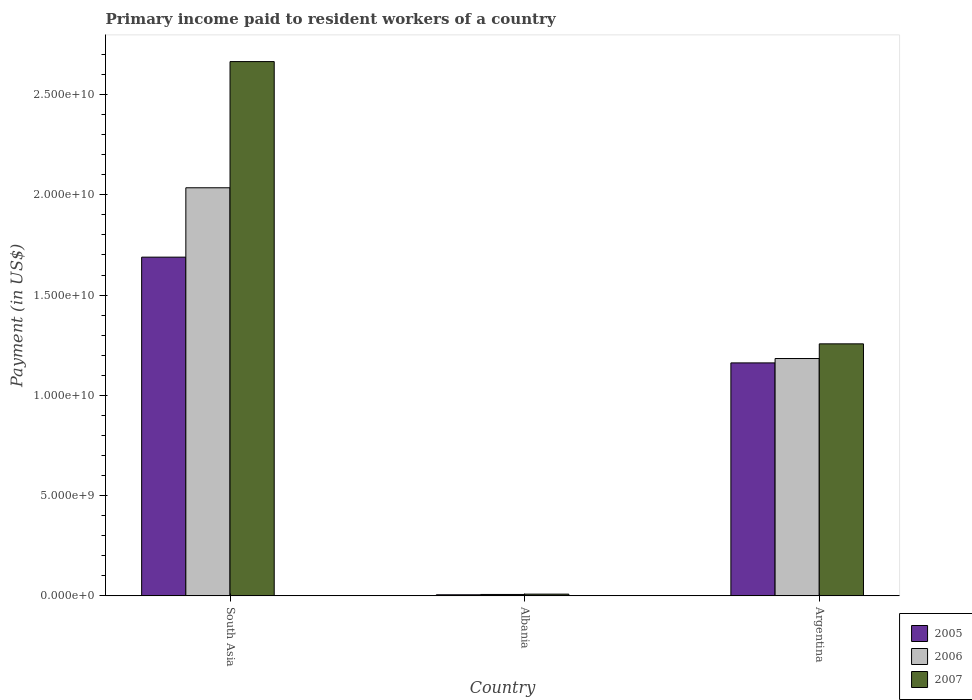How many different coloured bars are there?
Give a very brief answer. 3. How many groups of bars are there?
Make the answer very short. 3. Are the number of bars on each tick of the X-axis equal?
Keep it short and to the point. Yes. How many bars are there on the 2nd tick from the left?
Provide a succinct answer. 3. What is the label of the 2nd group of bars from the left?
Offer a terse response. Albania. What is the amount paid to workers in 2007 in South Asia?
Your answer should be very brief. 2.66e+1. Across all countries, what is the maximum amount paid to workers in 2007?
Provide a short and direct response. 2.66e+1. Across all countries, what is the minimum amount paid to workers in 2006?
Give a very brief answer. 6.91e+07. In which country was the amount paid to workers in 2006 minimum?
Make the answer very short. Albania. What is the total amount paid to workers in 2007 in the graph?
Provide a short and direct response. 3.93e+1. What is the difference between the amount paid to workers in 2007 in Albania and that in Argentina?
Make the answer very short. -1.25e+1. What is the difference between the amount paid to workers in 2005 in South Asia and the amount paid to workers in 2006 in Argentina?
Your response must be concise. 5.06e+09. What is the average amount paid to workers in 2005 per country?
Your answer should be compact. 9.52e+09. What is the difference between the amount paid to workers of/in 2006 and amount paid to workers of/in 2005 in Albania?
Your answer should be very brief. 1.65e+07. In how many countries, is the amount paid to workers in 2005 greater than 20000000000 US$?
Offer a terse response. 0. What is the ratio of the amount paid to workers in 2006 in Albania to that in Argentina?
Keep it short and to the point. 0.01. What is the difference between the highest and the second highest amount paid to workers in 2005?
Offer a very short reply. -5.27e+09. What is the difference between the highest and the lowest amount paid to workers in 2007?
Offer a very short reply. 2.66e+1. In how many countries, is the amount paid to workers in 2005 greater than the average amount paid to workers in 2005 taken over all countries?
Keep it short and to the point. 2. What does the 1st bar from the right in South Asia represents?
Your response must be concise. 2007. Is it the case that in every country, the sum of the amount paid to workers in 2007 and amount paid to workers in 2005 is greater than the amount paid to workers in 2006?
Make the answer very short. Yes. Are all the bars in the graph horizontal?
Offer a terse response. No. Does the graph contain any zero values?
Ensure brevity in your answer.  No. How many legend labels are there?
Make the answer very short. 3. How are the legend labels stacked?
Your response must be concise. Vertical. What is the title of the graph?
Ensure brevity in your answer.  Primary income paid to resident workers of a country. Does "2011" appear as one of the legend labels in the graph?
Your answer should be compact. No. What is the label or title of the X-axis?
Your answer should be compact. Country. What is the label or title of the Y-axis?
Provide a succinct answer. Payment (in US$). What is the Payment (in US$) in 2005 in South Asia?
Offer a very short reply. 1.69e+1. What is the Payment (in US$) in 2006 in South Asia?
Offer a terse response. 2.04e+1. What is the Payment (in US$) in 2007 in South Asia?
Keep it short and to the point. 2.66e+1. What is the Payment (in US$) in 2005 in Albania?
Ensure brevity in your answer.  5.26e+07. What is the Payment (in US$) of 2006 in Albania?
Provide a succinct answer. 6.91e+07. What is the Payment (in US$) of 2007 in Albania?
Ensure brevity in your answer.  8.51e+07. What is the Payment (in US$) in 2005 in Argentina?
Your answer should be very brief. 1.16e+1. What is the Payment (in US$) in 2006 in Argentina?
Give a very brief answer. 1.18e+1. What is the Payment (in US$) of 2007 in Argentina?
Offer a terse response. 1.26e+1. Across all countries, what is the maximum Payment (in US$) of 2005?
Offer a terse response. 1.69e+1. Across all countries, what is the maximum Payment (in US$) in 2006?
Your answer should be compact. 2.04e+1. Across all countries, what is the maximum Payment (in US$) of 2007?
Your response must be concise. 2.66e+1. Across all countries, what is the minimum Payment (in US$) of 2005?
Provide a short and direct response. 5.26e+07. Across all countries, what is the minimum Payment (in US$) in 2006?
Your response must be concise. 6.91e+07. Across all countries, what is the minimum Payment (in US$) in 2007?
Provide a short and direct response. 8.51e+07. What is the total Payment (in US$) of 2005 in the graph?
Your answer should be very brief. 2.86e+1. What is the total Payment (in US$) of 2006 in the graph?
Your answer should be compact. 3.23e+1. What is the total Payment (in US$) of 2007 in the graph?
Offer a terse response. 3.93e+1. What is the difference between the Payment (in US$) of 2005 in South Asia and that in Albania?
Offer a terse response. 1.68e+1. What is the difference between the Payment (in US$) of 2006 in South Asia and that in Albania?
Keep it short and to the point. 2.03e+1. What is the difference between the Payment (in US$) in 2007 in South Asia and that in Albania?
Offer a terse response. 2.66e+1. What is the difference between the Payment (in US$) of 2005 in South Asia and that in Argentina?
Your answer should be very brief. 5.27e+09. What is the difference between the Payment (in US$) in 2006 in South Asia and that in Argentina?
Provide a succinct answer. 8.52e+09. What is the difference between the Payment (in US$) in 2007 in South Asia and that in Argentina?
Provide a succinct answer. 1.41e+1. What is the difference between the Payment (in US$) of 2005 in Albania and that in Argentina?
Your answer should be very brief. -1.16e+1. What is the difference between the Payment (in US$) of 2006 in Albania and that in Argentina?
Offer a very short reply. -1.18e+1. What is the difference between the Payment (in US$) of 2007 in Albania and that in Argentina?
Provide a succinct answer. -1.25e+1. What is the difference between the Payment (in US$) of 2005 in South Asia and the Payment (in US$) of 2006 in Albania?
Give a very brief answer. 1.68e+1. What is the difference between the Payment (in US$) in 2005 in South Asia and the Payment (in US$) in 2007 in Albania?
Your answer should be compact. 1.68e+1. What is the difference between the Payment (in US$) of 2006 in South Asia and the Payment (in US$) of 2007 in Albania?
Offer a terse response. 2.03e+1. What is the difference between the Payment (in US$) of 2005 in South Asia and the Payment (in US$) of 2006 in Argentina?
Your answer should be very brief. 5.06e+09. What is the difference between the Payment (in US$) of 2005 in South Asia and the Payment (in US$) of 2007 in Argentina?
Your response must be concise. 4.32e+09. What is the difference between the Payment (in US$) in 2006 in South Asia and the Payment (in US$) in 2007 in Argentina?
Offer a very short reply. 7.78e+09. What is the difference between the Payment (in US$) of 2005 in Albania and the Payment (in US$) of 2006 in Argentina?
Keep it short and to the point. -1.18e+1. What is the difference between the Payment (in US$) of 2005 in Albania and the Payment (in US$) of 2007 in Argentina?
Your answer should be compact. -1.25e+1. What is the difference between the Payment (in US$) of 2006 in Albania and the Payment (in US$) of 2007 in Argentina?
Make the answer very short. -1.25e+1. What is the average Payment (in US$) of 2005 per country?
Your answer should be compact. 9.52e+09. What is the average Payment (in US$) in 2006 per country?
Your answer should be compact. 1.08e+1. What is the average Payment (in US$) of 2007 per country?
Keep it short and to the point. 1.31e+1. What is the difference between the Payment (in US$) of 2005 and Payment (in US$) of 2006 in South Asia?
Make the answer very short. -3.46e+09. What is the difference between the Payment (in US$) in 2005 and Payment (in US$) in 2007 in South Asia?
Your answer should be very brief. -9.75e+09. What is the difference between the Payment (in US$) in 2006 and Payment (in US$) in 2007 in South Asia?
Give a very brief answer. -6.29e+09. What is the difference between the Payment (in US$) of 2005 and Payment (in US$) of 2006 in Albania?
Give a very brief answer. -1.65e+07. What is the difference between the Payment (in US$) in 2005 and Payment (in US$) in 2007 in Albania?
Your answer should be compact. -3.25e+07. What is the difference between the Payment (in US$) of 2006 and Payment (in US$) of 2007 in Albania?
Make the answer very short. -1.60e+07. What is the difference between the Payment (in US$) of 2005 and Payment (in US$) of 2006 in Argentina?
Offer a terse response. -2.18e+08. What is the difference between the Payment (in US$) in 2005 and Payment (in US$) in 2007 in Argentina?
Ensure brevity in your answer.  -9.50e+08. What is the difference between the Payment (in US$) of 2006 and Payment (in US$) of 2007 in Argentina?
Offer a terse response. -7.31e+08. What is the ratio of the Payment (in US$) in 2005 in South Asia to that in Albania?
Offer a terse response. 321.04. What is the ratio of the Payment (in US$) of 2006 in South Asia to that in Albania?
Offer a very short reply. 294.52. What is the ratio of the Payment (in US$) in 2007 in South Asia to that in Albania?
Offer a terse response. 313.04. What is the ratio of the Payment (in US$) of 2005 in South Asia to that in Argentina?
Keep it short and to the point. 1.45. What is the ratio of the Payment (in US$) of 2006 in South Asia to that in Argentina?
Your answer should be compact. 1.72. What is the ratio of the Payment (in US$) in 2007 in South Asia to that in Argentina?
Make the answer very short. 2.12. What is the ratio of the Payment (in US$) of 2005 in Albania to that in Argentina?
Keep it short and to the point. 0. What is the ratio of the Payment (in US$) of 2006 in Albania to that in Argentina?
Provide a succinct answer. 0.01. What is the ratio of the Payment (in US$) in 2007 in Albania to that in Argentina?
Your response must be concise. 0.01. What is the difference between the highest and the second highest Payment (in US$) of 2005?
Keep it short and to the point. 5.27e+09. What is the difference between the highest and the second highest Payment (in US$) of 2006?
Ensure brevity in your answer.  8.52e+09. What is the difference between the highest and the second highest Payment (in US$) of 2007?
Keep it short and to the point. 1.41e+1. What is the difference between the highest and the lowest Payment (in US$) in 2005?
Your answer should be compact. 1.68e+1. What is the difference between the highest and the lowest Payment (in US$) of 2006?
Give a very brief answer. 2.03e+1. What is the difference between the highest and the lowest Payment (in US$) in 2007?
Ensure brevity in your answer.  2.66e+1. 